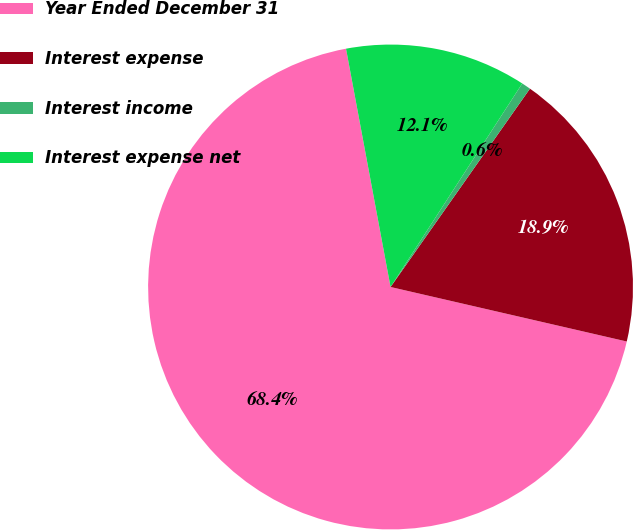<chart> <loc_0><loc_0><loc_500><loc_500><pie_chart><fcel>Year Ended December 31<fcel>Interest expense<fcel>Interest income<fcel>Interest expense net<nl><fcel>68.45%<fcel>18.86%<fcel>0.61%<fcel>12.08%<nl></chart> 